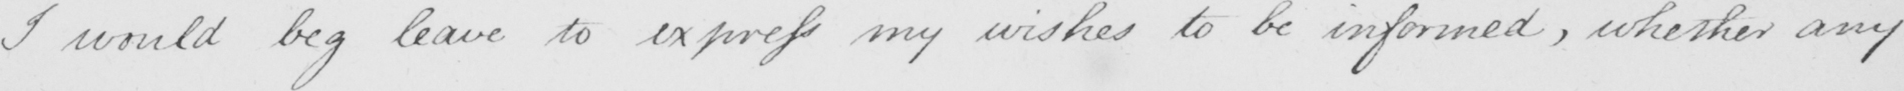What text is written in this handwritten line? I would beg leave to express my wishes to be informed , whether any 